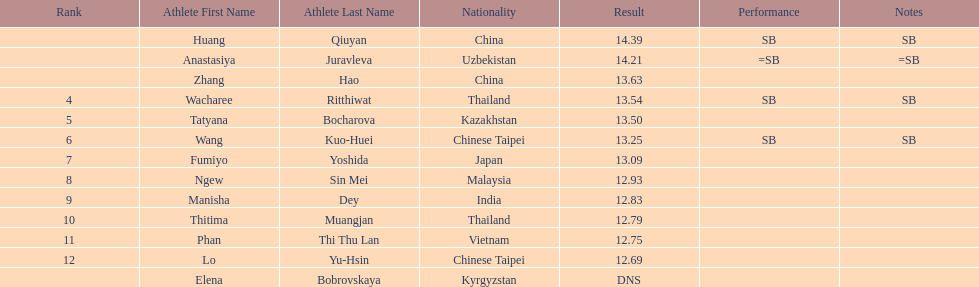How many people were ranked? 12. 